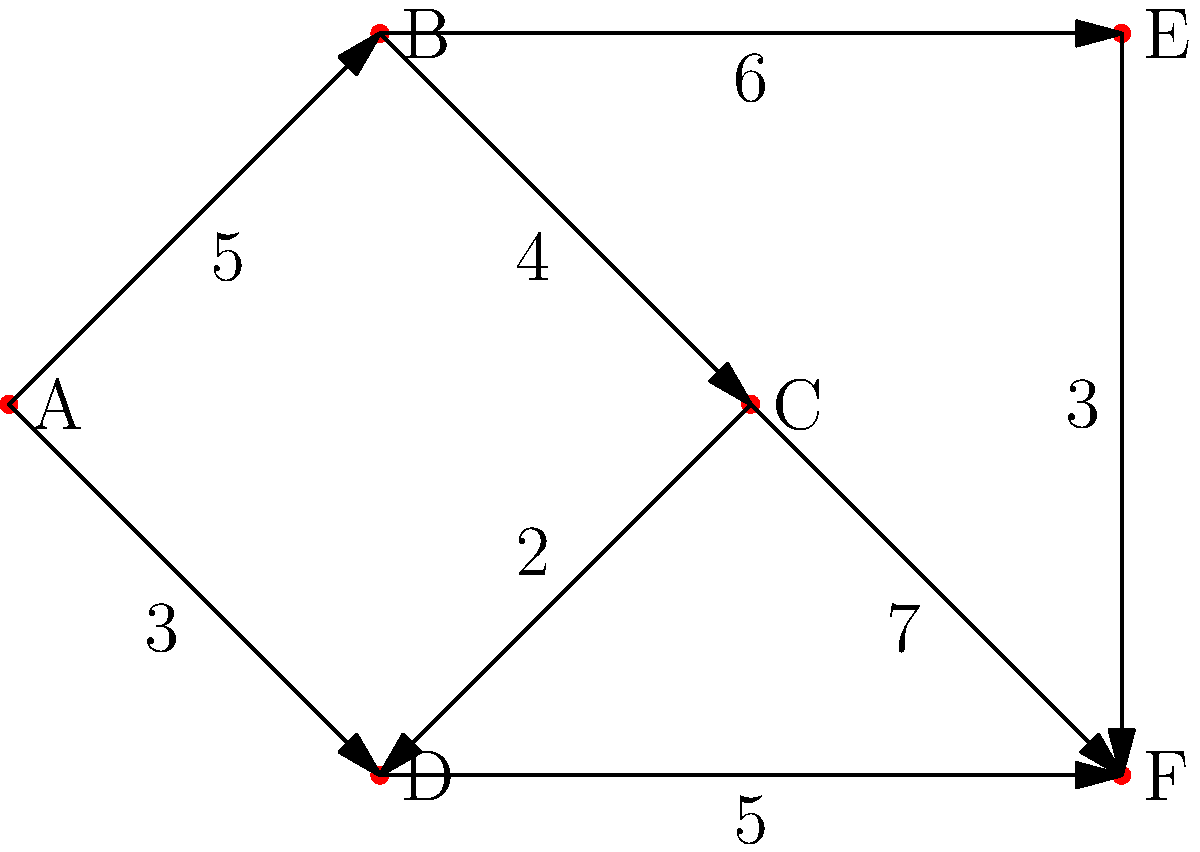As the owner of a sustainable fashion brand, you need to optimize your distribution network. The weighted graph represents different distribution centers (nodes) and the transportation costs between them (edge weights). Starting from your main warehouse at node A, what is the minimum total cost to reach all other distribution centers using a minimum spanning tree? To find the minimum spanning tree (MST) and its total cost, we'll use Prim's algorithm:

1. Start with node A as the initial vertex in the MST.
2. Consider all edges connected to vertices in the MST:
   - A-B (cost 5)
   - A-D (cost 3)
3. Choose the lowest cost edge: A-D (cost 3)
4. Add D to the MST. Now consider new edges:
   - A-B (cost 5)
   - D-C (cost 2)
   - D-F (cost 5)
5. Choose the lowest cost edge: D-C (cost 2)
6. Add C to the MST. Now consider new edges:
   - A-B (cost 5)
   - D-F (cost 5)
   - C-B (cost 4)
   - C-F (cost 7)
7. Choose the lowest cost edge: C-B (cost 4)
8. Add B to the MST. Now consider new edges:
   - D-F (cost 5)
   - C-F (cost 7)
   - B-E (cost 6)
9. Choose the lowest cost edge: B-E (cost 6)
10. Add E to the MST. Now consider new edges:
    - D-F (cost 5)
    - C-F (cost 7)
    - E-F (cost 3)
11. Choose the lowest cost edge: E-F (cost 3)
12. Add F to the MST. All nodes are now included.

The MST includes edges: A-D, D-C, C-B, B-E, E-F
Total cost: $3 + 2 + 4 + 6 + 3 = 18$
Answer: $18$ 